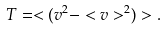Convert formula to latex. <formula><loc_0><loc_0><loc_500><loc_500>T = < ( v ^ { 2 } - < v > ^ { 2 } ) > .</formula> 